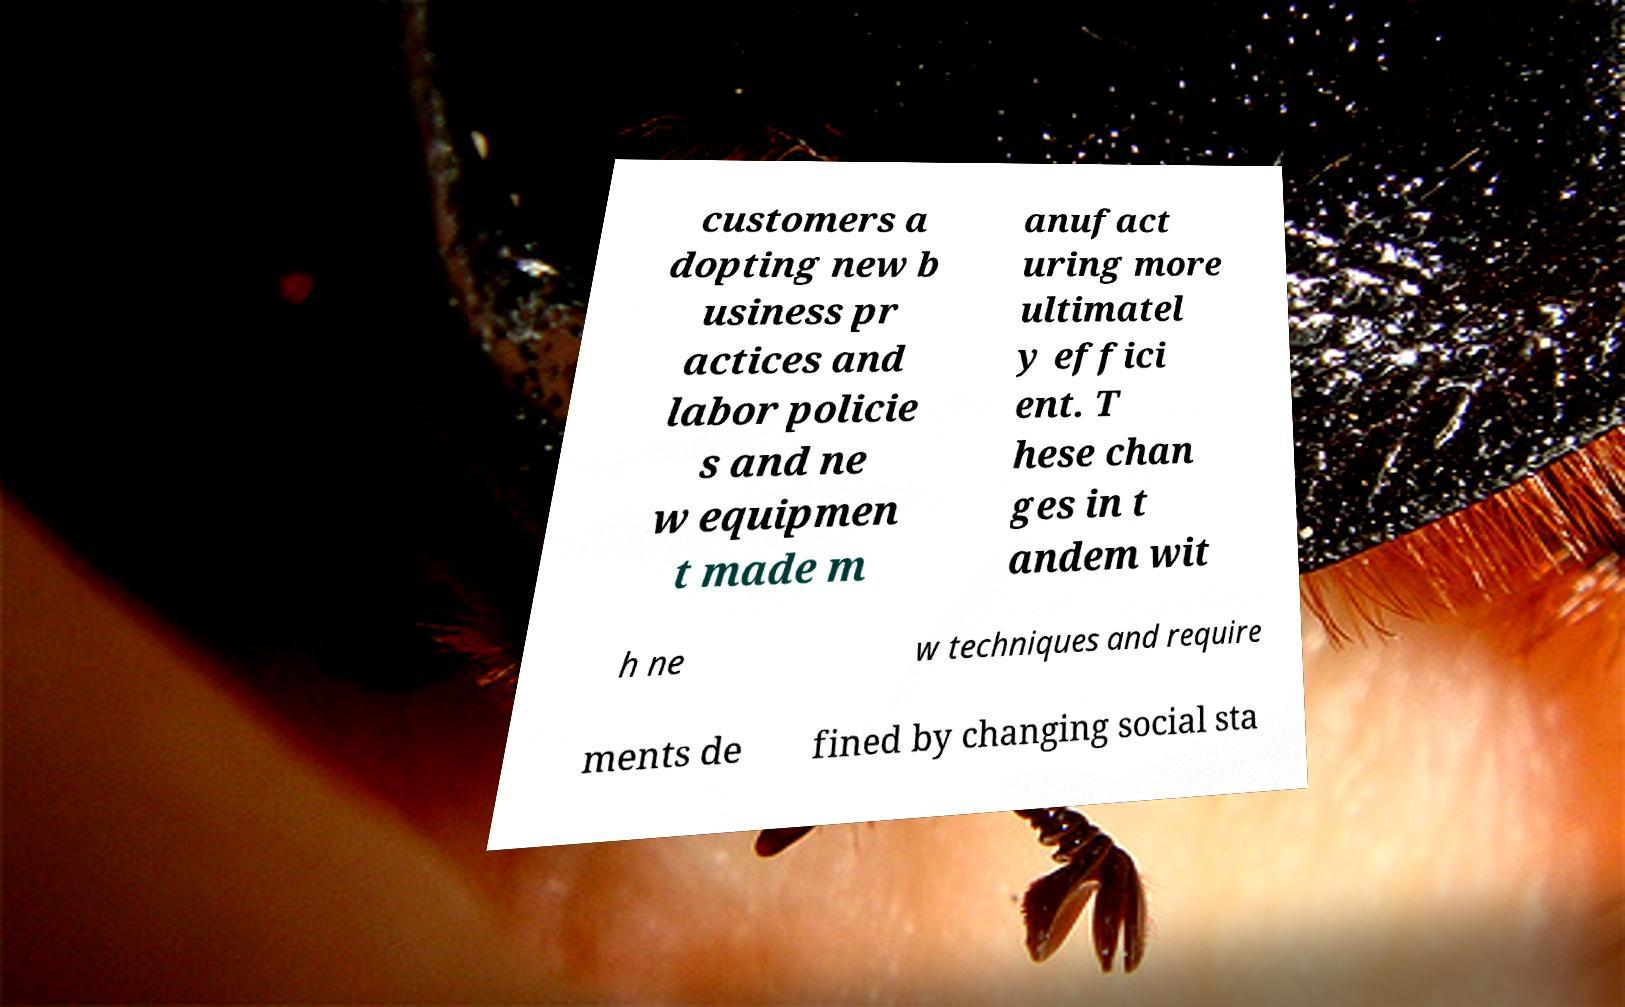For documentation purposes, I need the text within this image transcribed. Could you provide that? customers a dopting new b usiness pr actices and labor policie s and ne w equipmen t made m anufact uring more ultimatel y effici ent. T hese chan ges in t andem wit h ne w techniques and require ments de fined by changing social sta 